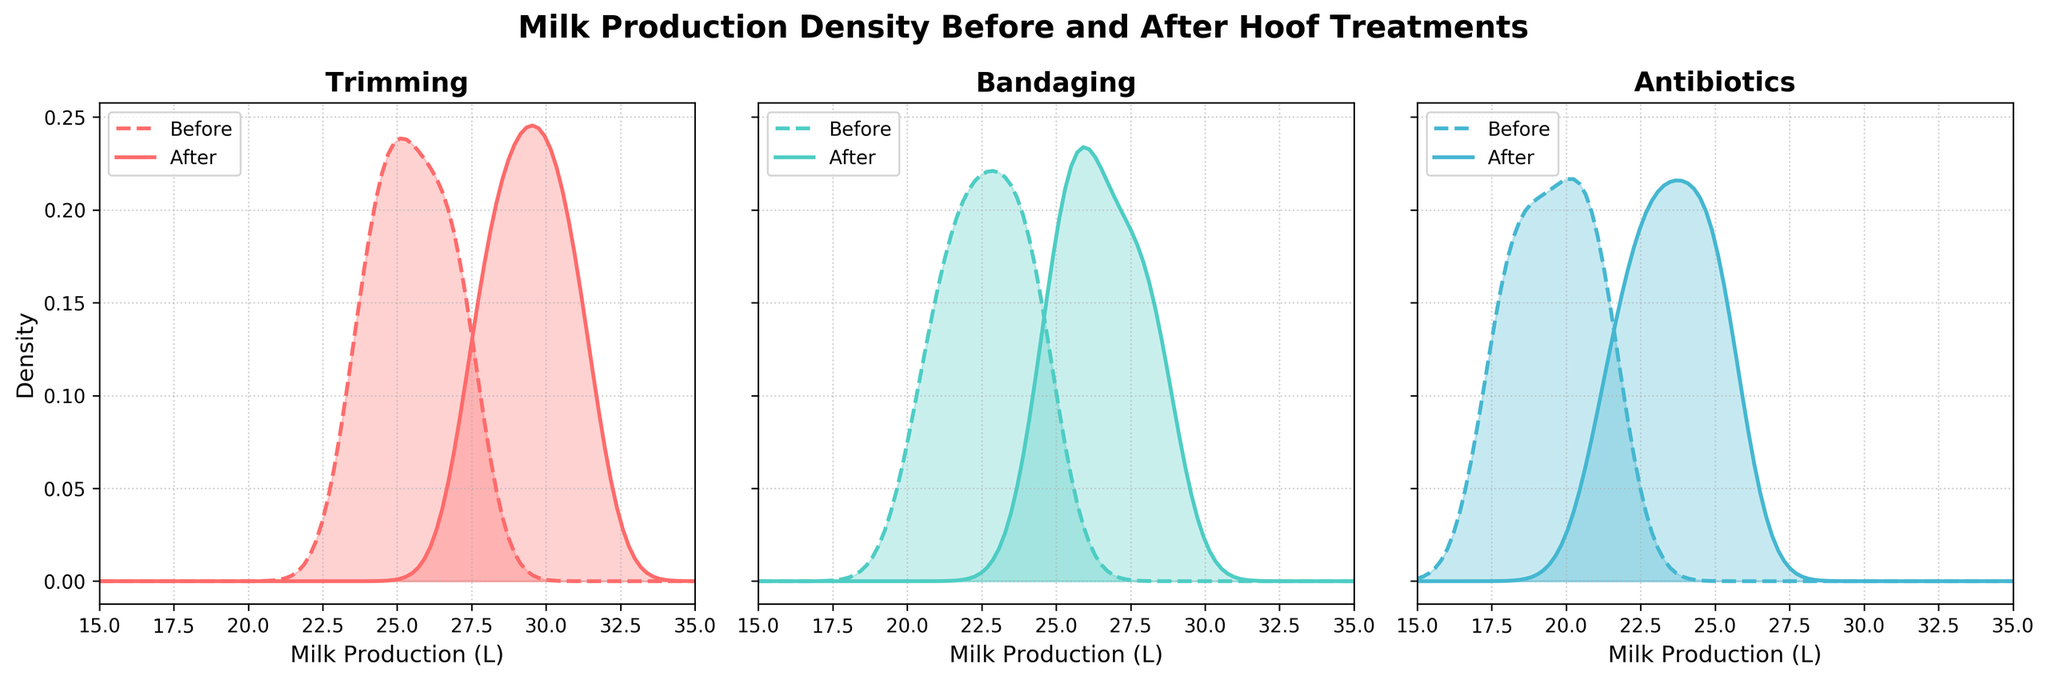What's the title of the figure? The title is located at the top of the figure. It reads "Milk Production Density Before and After Hoof Treatments".
Answer: Milk Production Density Before and After Hoof Treatments What are the three treatments compared in the figure? The treatments are labeled at the top of each subplot. They are "Trimming" for the left subplot, "Bandaging" for the middle subplot, and "Antibiotics" for the right subplot.
Answer: Trimming, Bandaging, Antibiotics How are the density curves visually differentiated between "Before" and "After" periods? The "Before" density curves are represented using dashed lines, while the "After" density curves use solid lines. Additionally, they both use shaded areas but share the same color across the treatments.
Answer: Dashed lines for "Before" and solid lines for "After" Which treatment shows the largest shift in milk production after the intervention? To determine the largest shift, one should compare the distance between the peaks of the "Before" and "After" density curves in each subplot. "Antibiotics" shows the largest horizontal shift to the right.
Answer: Antibiotics For which treatment does the "After" period show the highest density peak? By examining the height of the "After" density curves, we see that the peak for "Trimming" is the tallest among the "After" periods of all treatments.
Answer: Trimming What is the approximate milk production range where the density curves for "Bandaging" overlap the most? Observing the overlap between the before and after curves of "Bandaging", the most significant overlap occurs around the 20 to 25 liters range.
Answer: 20 to 25 liters Do any of the treatments show a decrease in milk production after treatment? We need to check if any "After" density curve shifts left compared to the "Before" curve. All treatments show a shift to the right, indicating an increase in milk production.
Answer: No What's the overall trend in milk production across all treatments after intervention? By looking at the rightward shift of "After" density curves for all treatments, we can conclude that there is a general increase in milk production after hoof treatments.
Answer: Increase Which treatment has the lowest peak in "Before" period? The height of the "Before" density peaks needs to be compared across treatments. "Antibiotics" has the lowest peak for the "Before" period.
Answer: Antibiotics How does the shape of the density curves for "Trimming" change from before to after the treatment? Comparing the "Trimming" subplots' curves directly, the "After" density curve seems more spread out and shifts to higher milk production values. This indicates increased milk production post-trimming with more variation.
Answer: More spread out and shifted to higher production values 